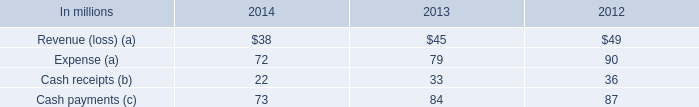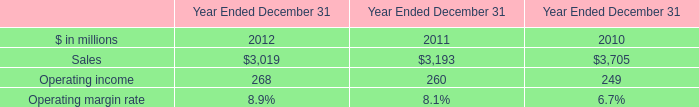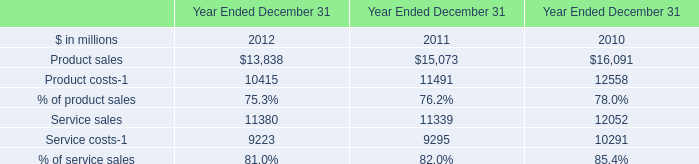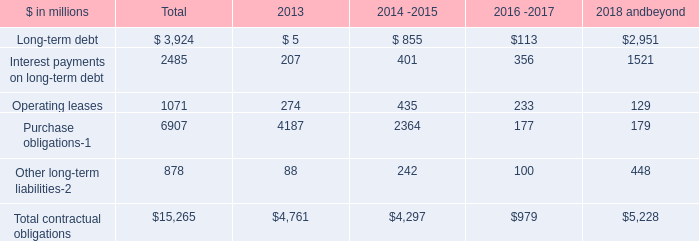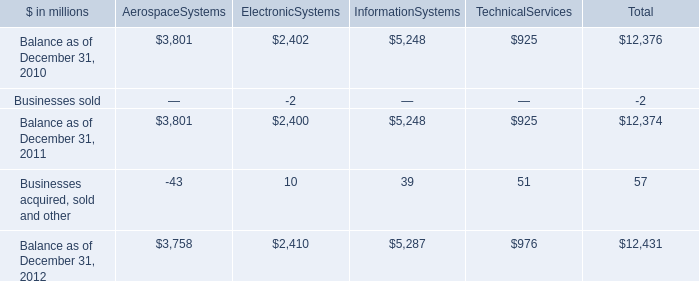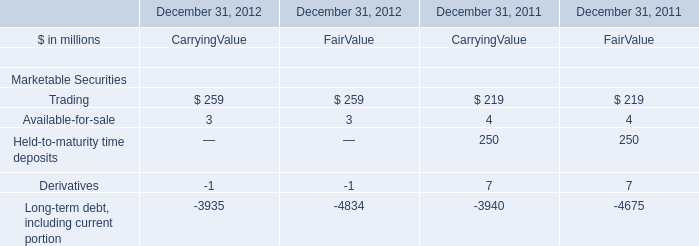What is the sum of Sales of Year Ended December 31 2010, and Balance as of December 31, 2010 of ElectronicSystems ? 
Computations: (3705.0 + 2402.0)
Answer: 6107.0. 